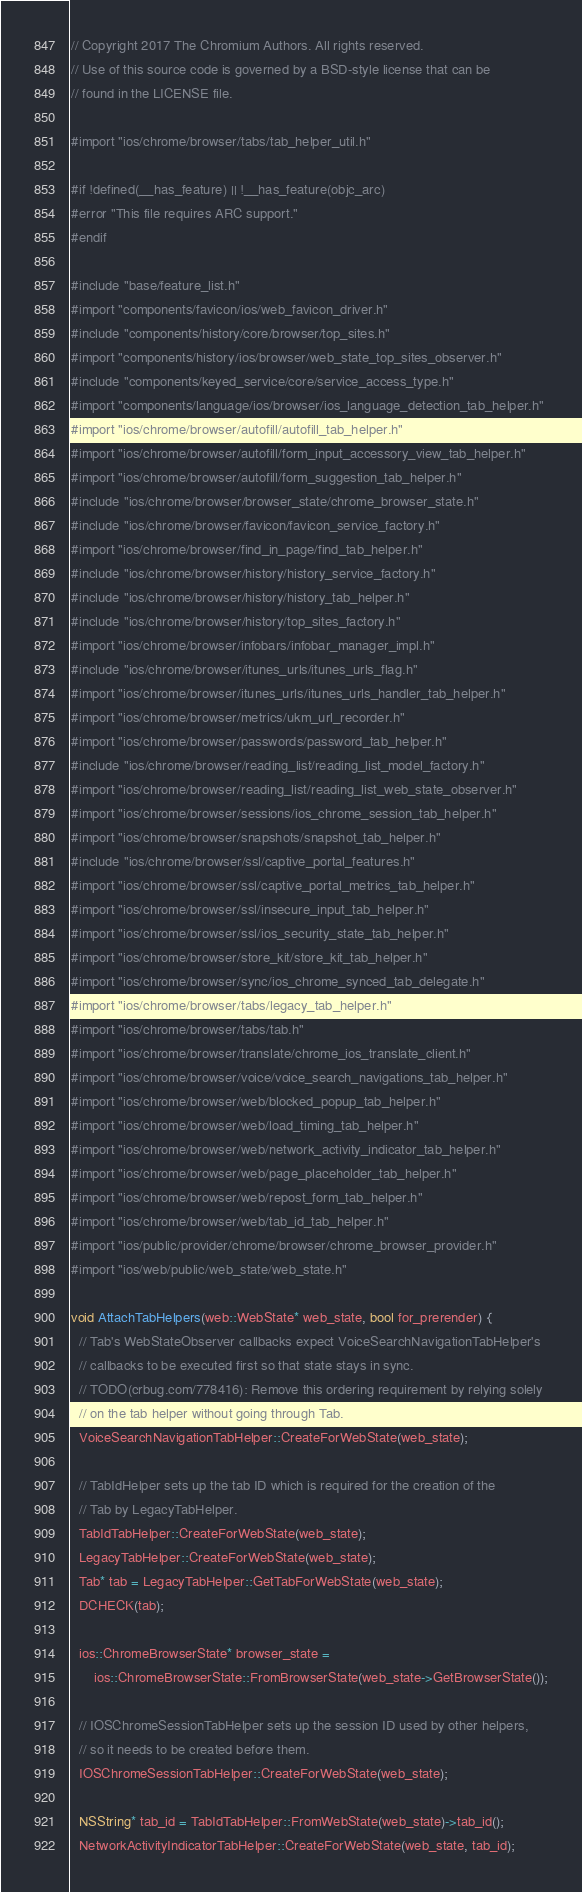<code> <loc_0><loc_0><loc_500><loc_500><_ObjectiveC_>// Copyright 2017 The Chromium Authors. All rights reserved.
// Use of this source code is governed by a BSD-style license that can be
// found in the LICENSE file.

#import "ios/chrome/browser/tabs/tab_helper_util.h"

#if !defined(__has_feature) || !__has_feature(objc_arc)
#error "This file requires ARC support."
#endif

#include "base/feature_list.h"
#import "components/favicon/ios/web_favicon_driver.h"
#include "components/history/core/browser/top_sites.h"
#import "components/history/ios/browser/web_state_top_sites_observer.h"
#include "components/keyed_service/core/service_access_type.h"
#import "components/language/ios/browser/ios_language_detection_tab_helper.h"
#import "ios/chrome/browser/autofill/autofill_tab_helper.h"
#import "ios/chrome/browser/autofill/form_input_accessory_view_tab_helper.h"
#import "ios/chrome/browser/autofill/form_suggestion_tab_helper.h"
#include "ios/chrome/browser/browser_state/chrome_browser_state.h"
#include "ios/chrome/browser/favicon/favicon_service_factory.h"
#import "ios/chrome/browser/find_in_page/find_tab_helper.h"
#include "ios/chrome/browser/history/history_service_factory.h"
#include "ios/chrome/browser/history/history_tab_helper.h"
#include "ios/chrome/browser/history/top_sites_factory.h"
#import "ios/chrome/browser/infobars/infobar_manager_impl.h"
#include "ios/chrome/browser/itunes_urls/itunes_urls_flag.h"
#import "ios/chrome/browser/itunes_urls/itunes_urls_handler_tab_helper.h"
#import "ios/chrome/browser/metrics/ukm_url_recorder.h"
#import "ios/chrome/browser/passwords/password_tab_helper.h"
#include "ios/chrome/browser/reading_list/reading_list_model_factory.h"
#import "ios/chrome/browser/reading_list/reading_list_web_state_observer.h"
#import "ios/chrome/browser/sessions/ios_chrome_session_tab_helper.h"
#import "ios/chrome/browser/snapshots/snapshot_tab_helper.h"
#include "ios/chrome/browser/ssl/captive_portal_features.h"
#import "ios/chrome/browser/ssl/captive_portal_metrics_tab_helper.h"
#import "ios/chrome/browser/ssl/insecure_input_tab_helper.h"
#import "ios/chrome/browser/ssl/ios_security_state_tab_helper.h"
#import "ios/chrome/browser/store_kit/store_kit_tab_helper.h"
#import "ios/chrome/browser/sync/ios_chrome_synced_tab_delegate.h"
#import "ios/chrome/browser/tabs/legacy_tab_helper.h"
#import "ios/chrome/browser/tabs/tab.h"
#import "ios/chrome/browser/translate/chrome_ios_translate_client.h"
#import "ios/chrome/browser/voice/voice_search_navigations_tab_helper.h"
#import "ios/chrome/browser/web/blocked_popup_tab_helper.h"
#import "ios/chrome/browser/web/load_timing_tab_helper.h"
#import "ios/chrome/browser/web/network_activity_indicator_tab_helper.h"
#import "ios/chrome/browser/web/page_placeholder_tab_helper.h"
#import "ios/chrome/browser/web/repost_form_tab_helper.h"
#import "ios/chrome/browser/web/tab_id_tab_helper.h"
#import "ios/public/provider/chrome/browser/chrome_browser_provider.h"
#import "ios/web/public/web_state/web_state.h"

void AttachTabHelpers(web::WebState* web_state, bool for_prerender) {
  // Tab's WebStateObserver callbacks expect VoiceSearchNavigationTabHelper's
  // callbacks to be executed first so that state stays in sync.
  // TODO(crbug.com/778416): Remove this ordering requirement by relying solely
  // on the tab helper without going through Tab.
  VoiceSearchNavigationTabHelper::CreateForWebState(web_state);

  // TabIdHelper sets up the tab ID which is required for the creation of the
  // Tab by LegacyTabHelper.
  TabIdTabHelper::CreateForWebState(web_state);
  LegacyTabHelper::CreateForWebState(web_state);
  Tab* tab = LegacyTabHelper::GetTabForWebState(web_state);
  DCHECK(tab);

  ios::ChromeBrowserState* browser_state =
      ios::ChromeBrowserState::FromBrowserState(web_state->GetBrowserState());

  // IOSChromeSessionTabHelper sets up the session ID used by other helpers,
  // so it needs to be created before them.
  IOSChromeSessionTabHelper::CreateForWebState(web_state);

  NSString* tab_id = TabIdTabHelper::FromWebState(web_state)->tab_id();
  NetworkActivityIndicatorTabHelper::CreateForWebState(web_state, tab_id);</code> 